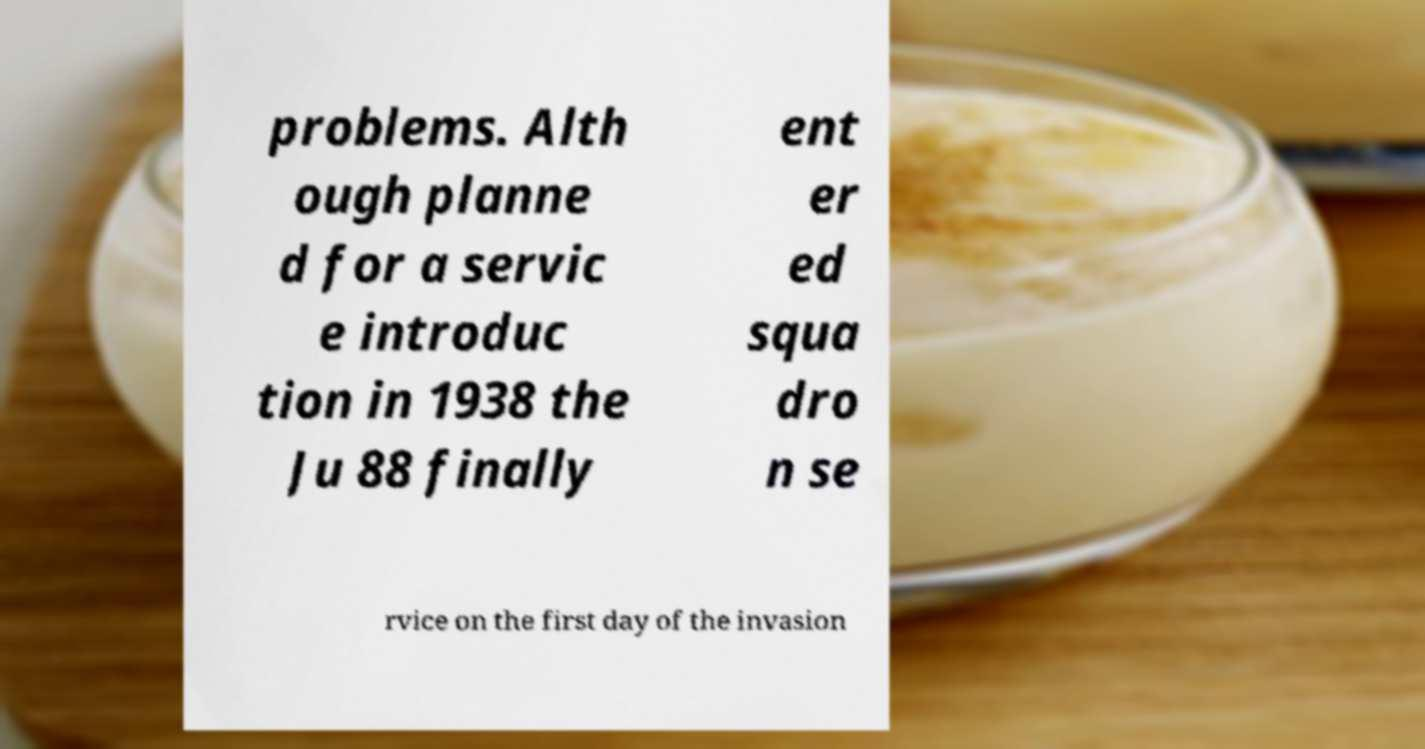Can you read and provide the text displayed in the image?This photo seems to have some interesting text. Can you extract and type it out for me? problems. Alth ough planne d for a servic e introduc tion in 1938 the Ju 88 finally ent er ed squa dro n se rvice on the first day of the invasion 